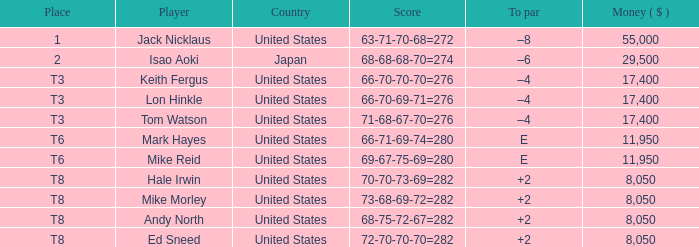What to par is located in the united states and has the player by the name of hale irwin? 2.0. 